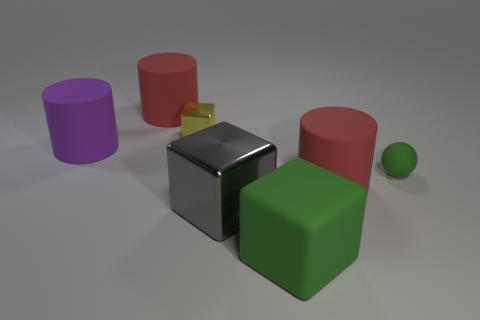There is a red object that is left of the big gray thing; what number of purple cylinders are left of it?
Keep it short and to the point. 1. Is the color of the large matte cylinder that is behind the small metallic thing the same as the small metallic object?
Make the answer very short. No. Are there any red objects on the right side of the red object that is left of the metallic cube in front of the tiny green thing?
Provide a succinct answer. Yes. What shape is the big matte thing that is both behind the large shiny block and on the right side of the gray thing?
Your answer should be compact. Cylinder. Is there a big object of the same color as the tiny rubber thing?
Provide a short and direct response. Yes. The sphere behind the red cylinder that is in front of the purple matte object is what color?
Offer a very short reply. Green. There is a red matte cylinder right of the green object that is in front of the red object that is on the right side of the big gray cube; what size is it?
Offer a very short reply. Large. Is the material of the tiny green ball the same as the red cylinder that is in front of the big purple rubber object?
Keep it short and to the point. Yes. The cube that is made of the same material as the gray object is what size?
Your response must be concise. Small. Are there any other large rubber things of the same shape as the big gray thing?
Ensure brevity in your answer.  Yes. 